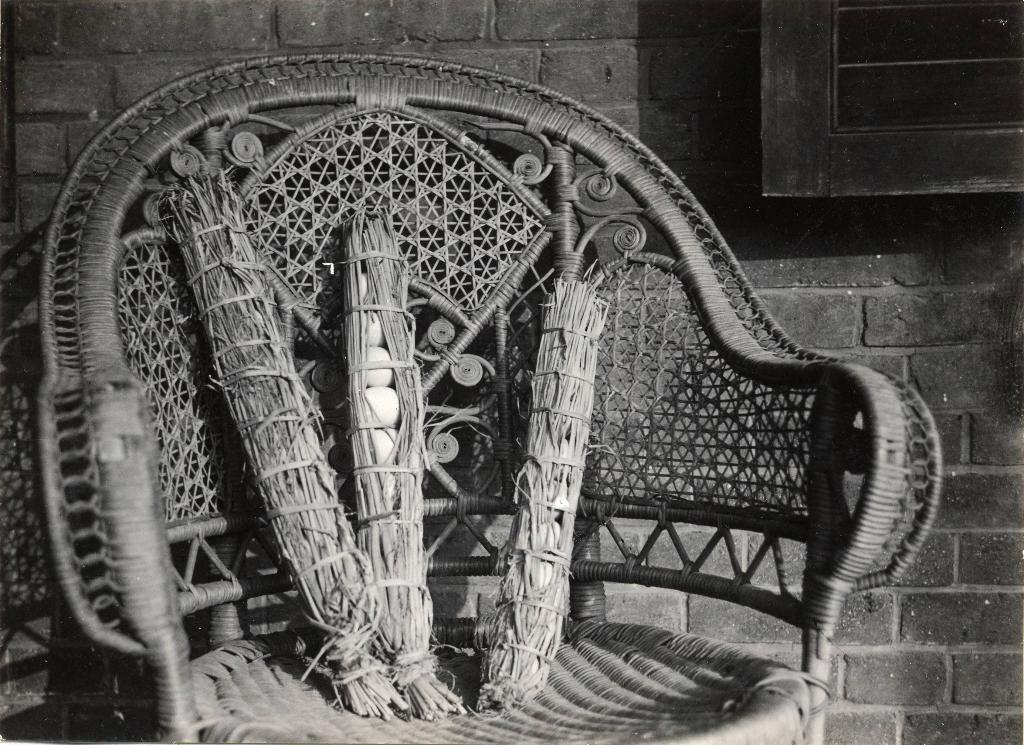Describe this image in one or two sentences. This is a black and white image. In the center there is a wooden chair placed on the ground and there are some objects placed on the chair. In the background we can see a brick wall and a window. 